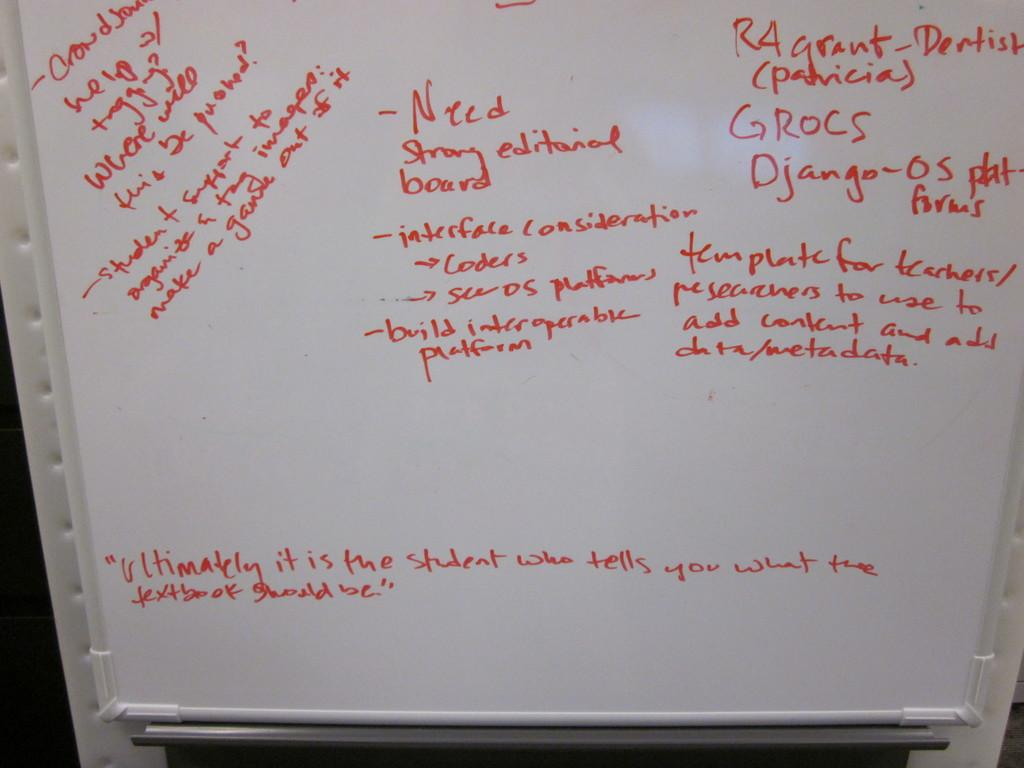<image>
Offer a succinct explanation of the picture presented. A white board with red writing indicates that someone needs a "strong editorial board." 